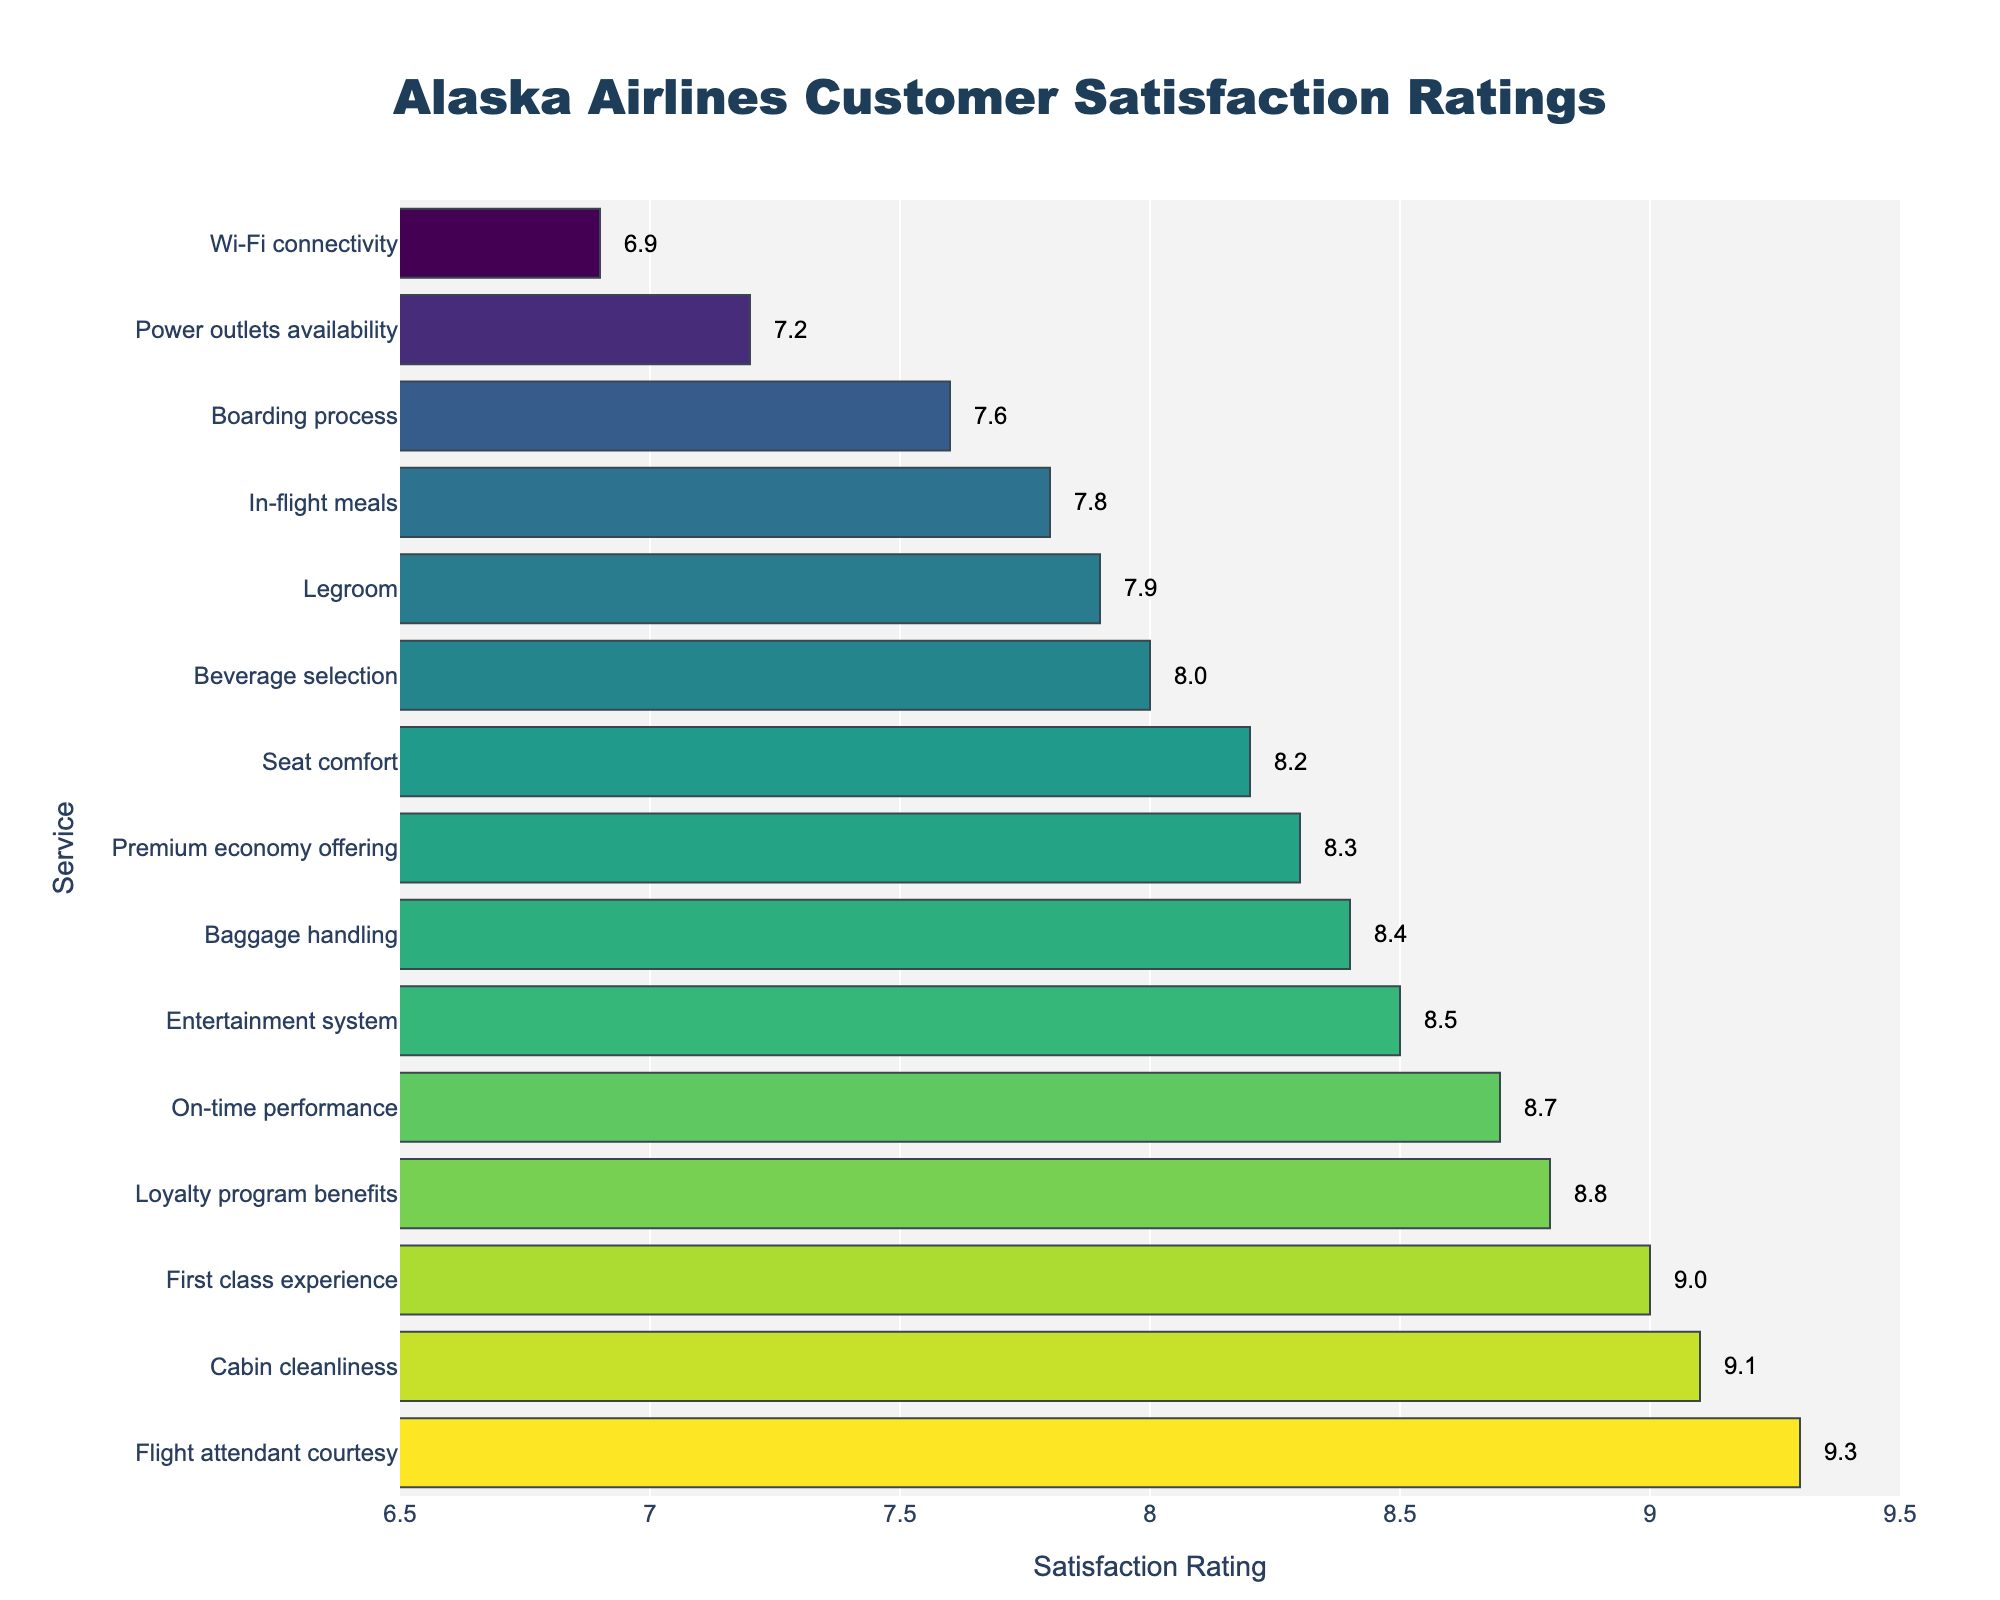What's the highest-rated service? The highest satisfaction rating shows the most favored service. Flight attendant courtesy rating is higher than all other services at 9.3.
Answer: Flight attendant courtesy What is the second lowest-rated service? The second lowest-rated service is found by identifying the bars with the second smallest satisfaction rating. Boarding process has the second lowest rating at 7.6, just above Wi-Fi connectivity at 6.9.
Answer: Boarding process How much higher is the satisfaction rating for Cabin cleanliness compared to Wi-Fi connectivity? Subtract the rating of Wi-Fi connectivity (6.9) from Cabin cleanliness (9.1). The difference is 9.1 - 6.9 = 2.2.
Answer: 2.2 Which service has a higher rating: Beverage selection or Boarding process? Look at the ratings for each: Beverage selection is rated 8.0, and Boarding process is rated 7.6. Beverage selection has the higher rating.
Answer: Beverage selection What is the average satisfaction rating for the top 3 rated services? Add the satisfaction ratings of the top 3 services: Flight attendant courtesy (9.3), Cabin cleanliness (9.1), and First class experience (9.0). The sum is 9.3 + 9.1 + 9.0 = 27.4. Divide by 3 to get the average: 27.4 / 3 = 9.13.
Answer: 9.13 How does the rating of Seat comfort compare to the rating of On-time performance? Seat comfort has a rating of 8.2 while On-time performance has a rating of 8.7. On-time performance has a higher rating.
Answer: On-time performance What is the difference in satisfaction ratings between the highest and lowest rated services? The highest rated service is Flight attendant courtesy at 9.3 and the lowest is Wi-Fi connectivity at 6.9. The difference is 9.3 - 6.9 = 2.4.
Answer: 2.4 What can be said about the length of bars representing the top 5 services and bottom 5 services? The bars for the top 5 services (Flight attendant courtesy, Cabin cleanliness, First class experience, Loyalty program benefits, On-time performance) are significantly longer than those for the bottom 5 services (Wi-Fi connectivity, Boarding process, Power outlets availability, In-flight meals, Legroom). This shows higher satisfaction levels in the top-rated services.
Answer: Top 5 are longer Which service has a similar satisfaction rating to Legroom? Legroom has a rating of 7.9. The service with a very close rating to it is In-flight meals with a rating of 7.8.
Answer: In-flight meals Is the rating for Entertainment system higher or lower than the average rating for all services? Calculate the average of all ratings by summing them (7.8 + 8.2 + 6.9 + 8.5 + 9.1 + 9.3 + 8.0 + 8.7 + 8.4 + 7.6 + 7.9 + 7.2 + 8.8 + 9.0 + 8.3 = 123.7) and dividing by 15 (number of services): 123.7 / 15 = 8.25. The rating for the Entertainment system (8.5) is higher than the average rating (8.25).
Answer: Higher 